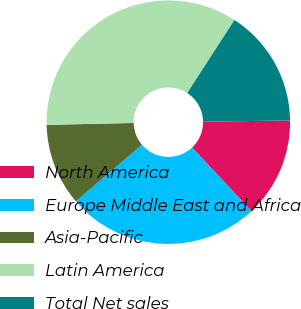Convert chart to OTSL. <chart><loc_0><loc_0><loc_500><loc_500><pie_chart><fcel>North America<fcel>Europe Middle East and Africa<fcel>Asia-Pacific<fcel>Latin America<fcel>Total Net sales<nl><fcel>13.27%<fcel>25.7%<fcel>10.91%<fcel>34.49%<fcel>15.63%<nl></chart> 